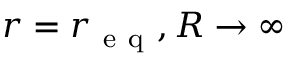Convert formula to latex. <formula><loc_0><loc_0><loc_500><loc_500>r = r _ { e q } , R \to \infty</formula> 